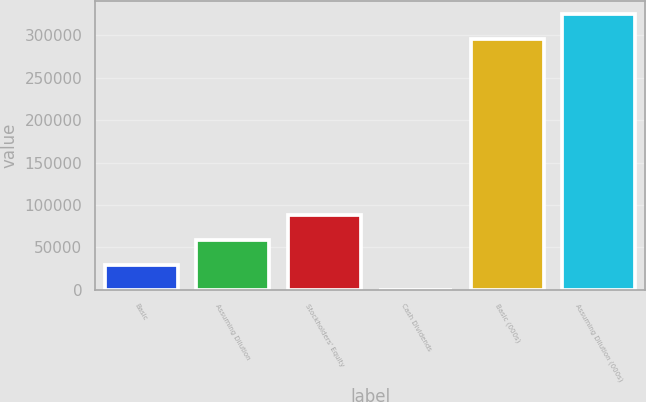<chart> <loc_0><loc_0><loc_500><loc_500><bar_chart><fcel>Basic<fcel>Assuming Dilution<fcel>Stockholders' Equity<fcel>Cash Dividends<fcel>Basic (000s)<fcel>Assuming Dilution (000s)<nl><fcel>29522.7<fcel>59045.1<fcel>88567.5<fcel>0.3<fcel>295224<fcel>324747<nl></chart> 